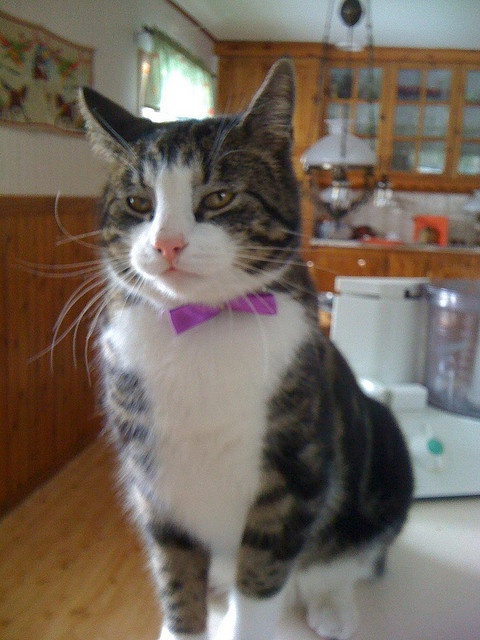Describe the objects in this image and their specific colors. I can see cat in gray, darkgray, and black tones and tie in gray and purple tones in this image. 